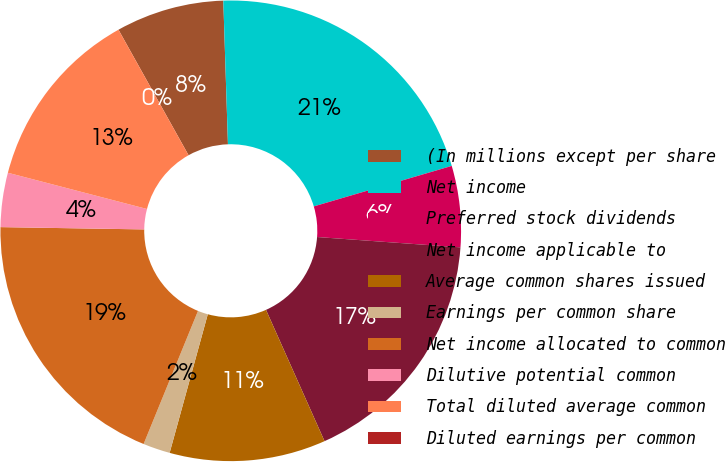Convert chart. <chart><loc_0><loc_0><loc_500><loc_500><pie_chart><fcel>(In millions except per share<fcel>Net income<fcel>Preferred stock dividends<fcel>Net income applicable to<fcel>Average common shares issued<fcel>Earnings per common share<fcel>Net income allocated to common<fcel>Dilutive potential common<fcel>Total diluted average common<fcel>Diluted earnings per common<nl><fcel>7.59%<fcel>20.97%<fcel>5.69%<fcel>17.18%<fcel>10.95%<fcel>1.9%<fcel>19.08%<fcel>3.8%<fcel>12.84%<fcel>0.0%<nl></chart> 